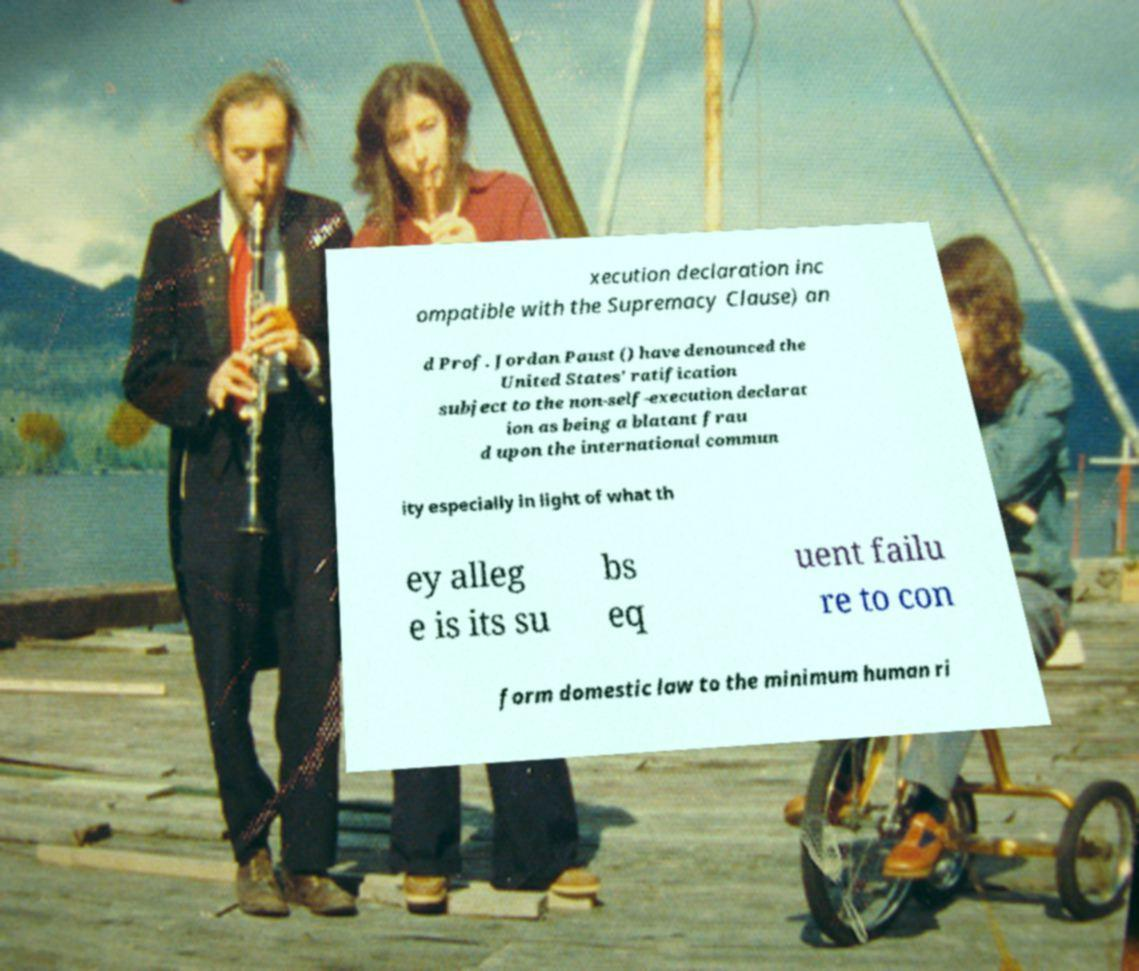Can you accurately transcribe the text from the provided image for me? xecution declaration inc ompatible with the Supremacy Clause) an d Prof. Jordan Paust () have denounced the United States' ratification subject to the non-self-execution declarat ion as being a blatant frau d upon the international commun ity especially in light of what th ey alleg e is its su bs eq uent failu re to con form domestic law to the minimum human ri 